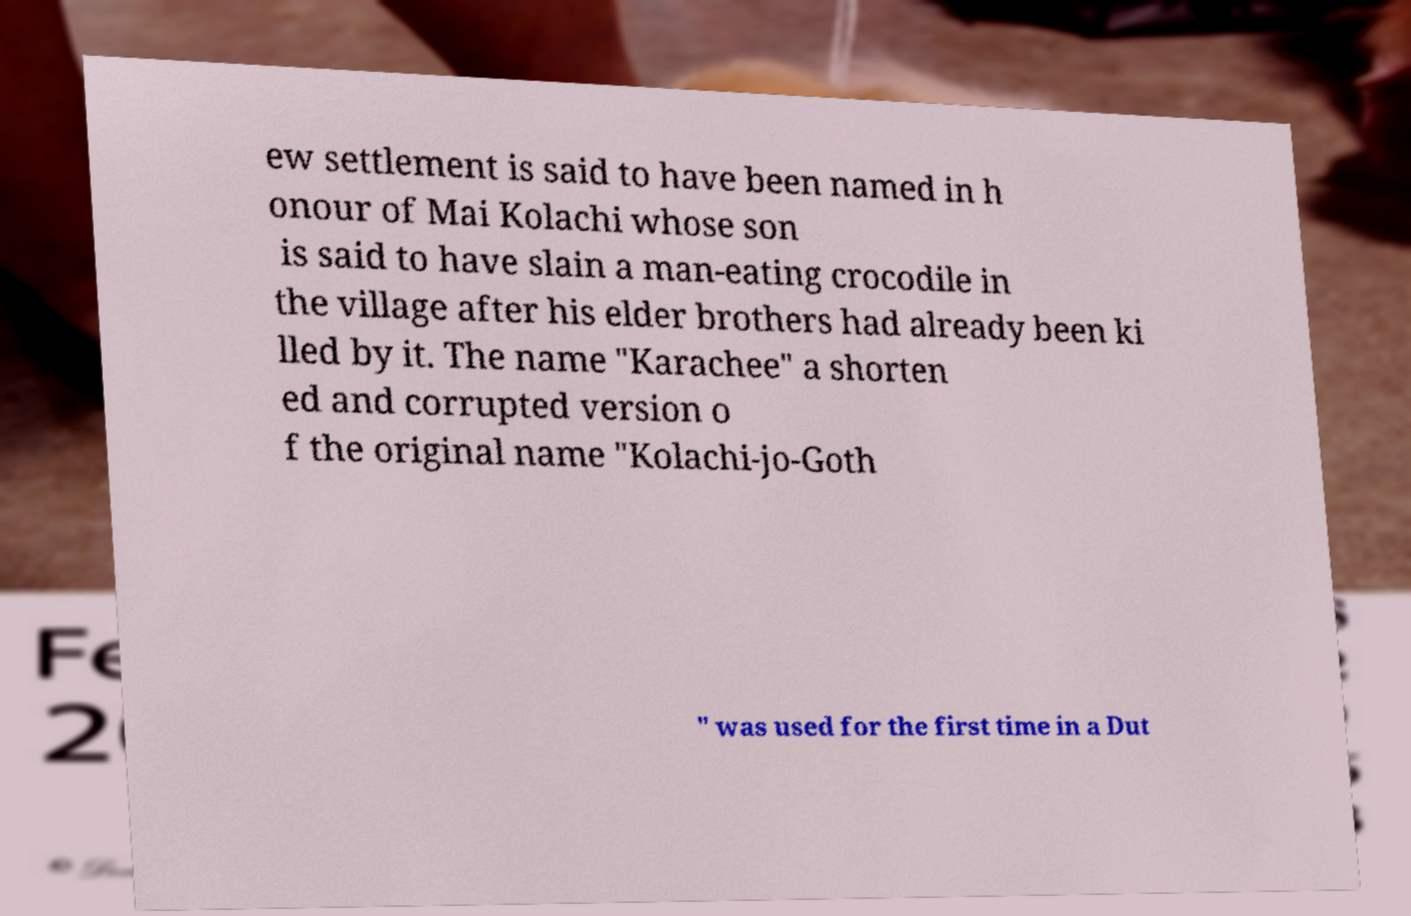What messages or text are displayed in this image? I need them in a readable, typed format. ew settlement is said to have been named in h onour of Mai Kolachi whose son is said to have slain a man-eating crocodile in the village after his elder brothers had already been ki lled by it. The name "Karachee" a shorten ed and corrupted version o f the original name "Kolachi-jo-Goth " was used for the first time in a Dut 